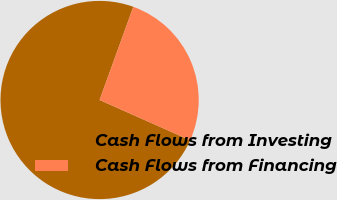<chart> <loc_0><loc_0><loc_500><loc_500><pie_chart><fcel>Cash Flows from Investing<fcel>Cash Flows from Financing<nl><fcel>73.87%<fcel>26.13%<nl></chart> 